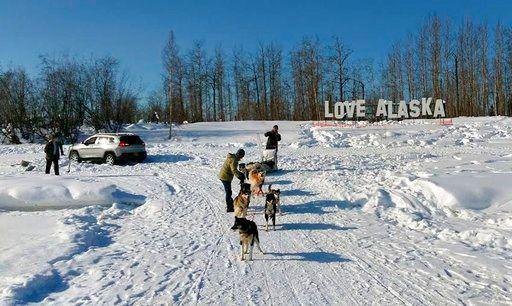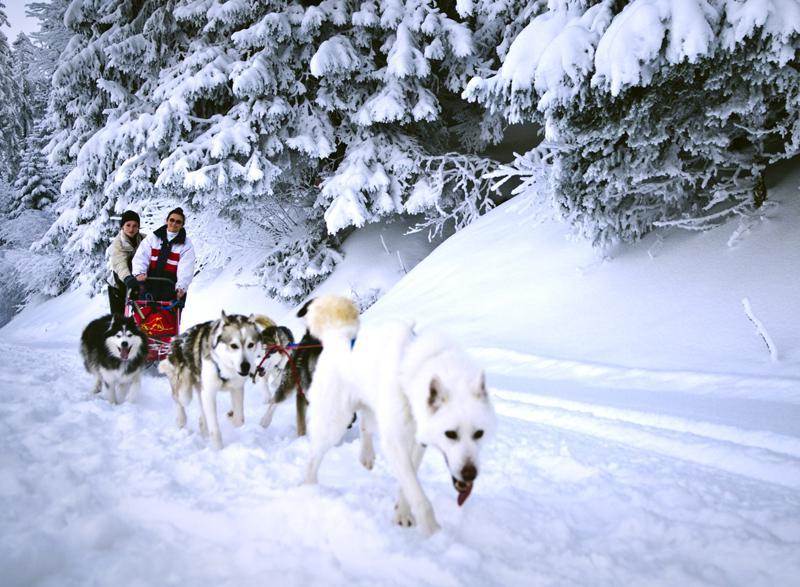The first image is the image on the left, the second image is the image on the right. Analyze the images presented: Is the assertion "All dog sled teams are heading diagonally to the left with evergreen trees in the background." valid? Answer yes or no. No. 